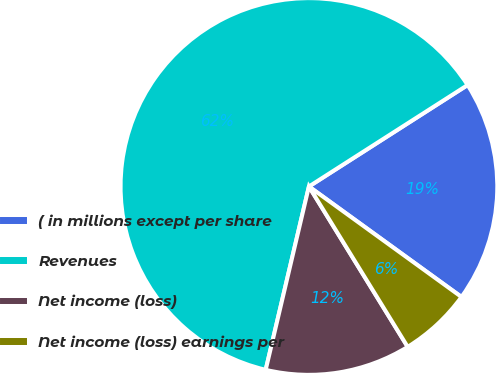Convert chart. <chart><loc_0><loc_0><loc_500><loc_500><pie_chart><fcel>( in millions except per share<fcel>Revenues<fcel>Net income (loss)<fcel>Net income (loss) earnings per<nl><fcel>19.03%<fcel>62.26%<fcel>12.47%<fcel>6.24%<nl></chart> 